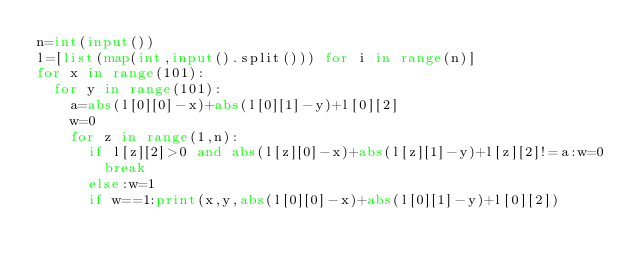<code> <loc_0><loc_0><loc_500><loc_500><_Python_>n=int(input())
l=[list(map(int,input().split())) for i in range(n)]
for x in range(101):
  for y in range(101):
    a=abs(l[0][0]-x)+abs(l[0][1]-y)+l[0][2]
    w=0
    for z in range(1,n):
      if l[z][2]>0 and abs(l[z][0]-x)+abs(l[z][1]-y)+l[z][2]!=a:w=0
        break
      else:w=1
      if w==1:print(x,y,abs(l[0][0]-x)+abs(l[0][1]-y)+l[0][2])</code> 